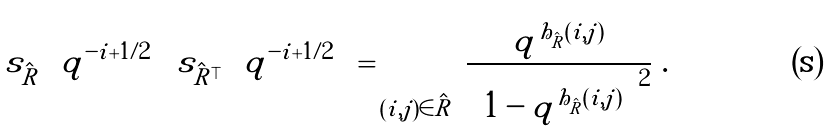<formula> <loc_0><loc_0><loc_500><loc_500>s _ { \hat { R } } \left ( q ^ { - i + { 1 } / { 2 } } \right ) \, s _ { { \hat { R } } ^ { \top } } \left ( q ^ { - i + { 1 } / { 2 } } \right ) = \prod _ { ( i , j ) \in { \hat { R } } } \, \frac { q ^ { h _ { \hat { R } } ( i , j ) } } { \left ( 1 - q ^ { h _ { \hat { R } } ( i , j ) } \right ) ^ { 2 } } \ .</formula> 